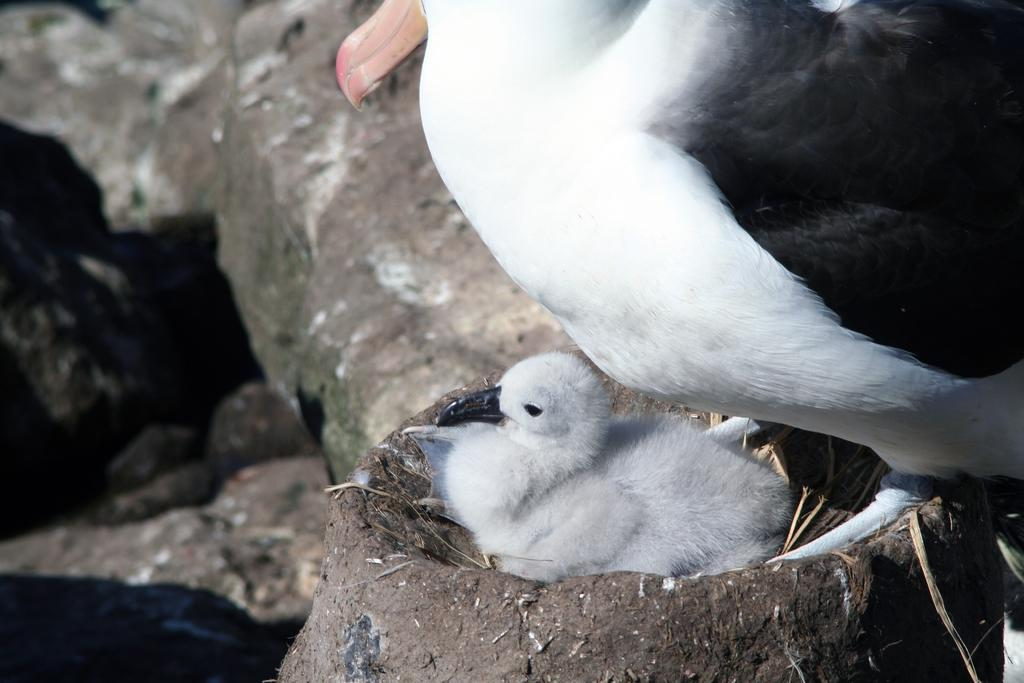How many birds can be seen in the image? There are two birds in the image. Where are the birds located? The birds are on a nest. Can you describe the background of the image? The background of the image is blurry. What type of pipe can be seen in the image? There is no pipe present in the image. Are the birds sleeping in the image? The image does not provide information about whether the birds are sleeping or not. 